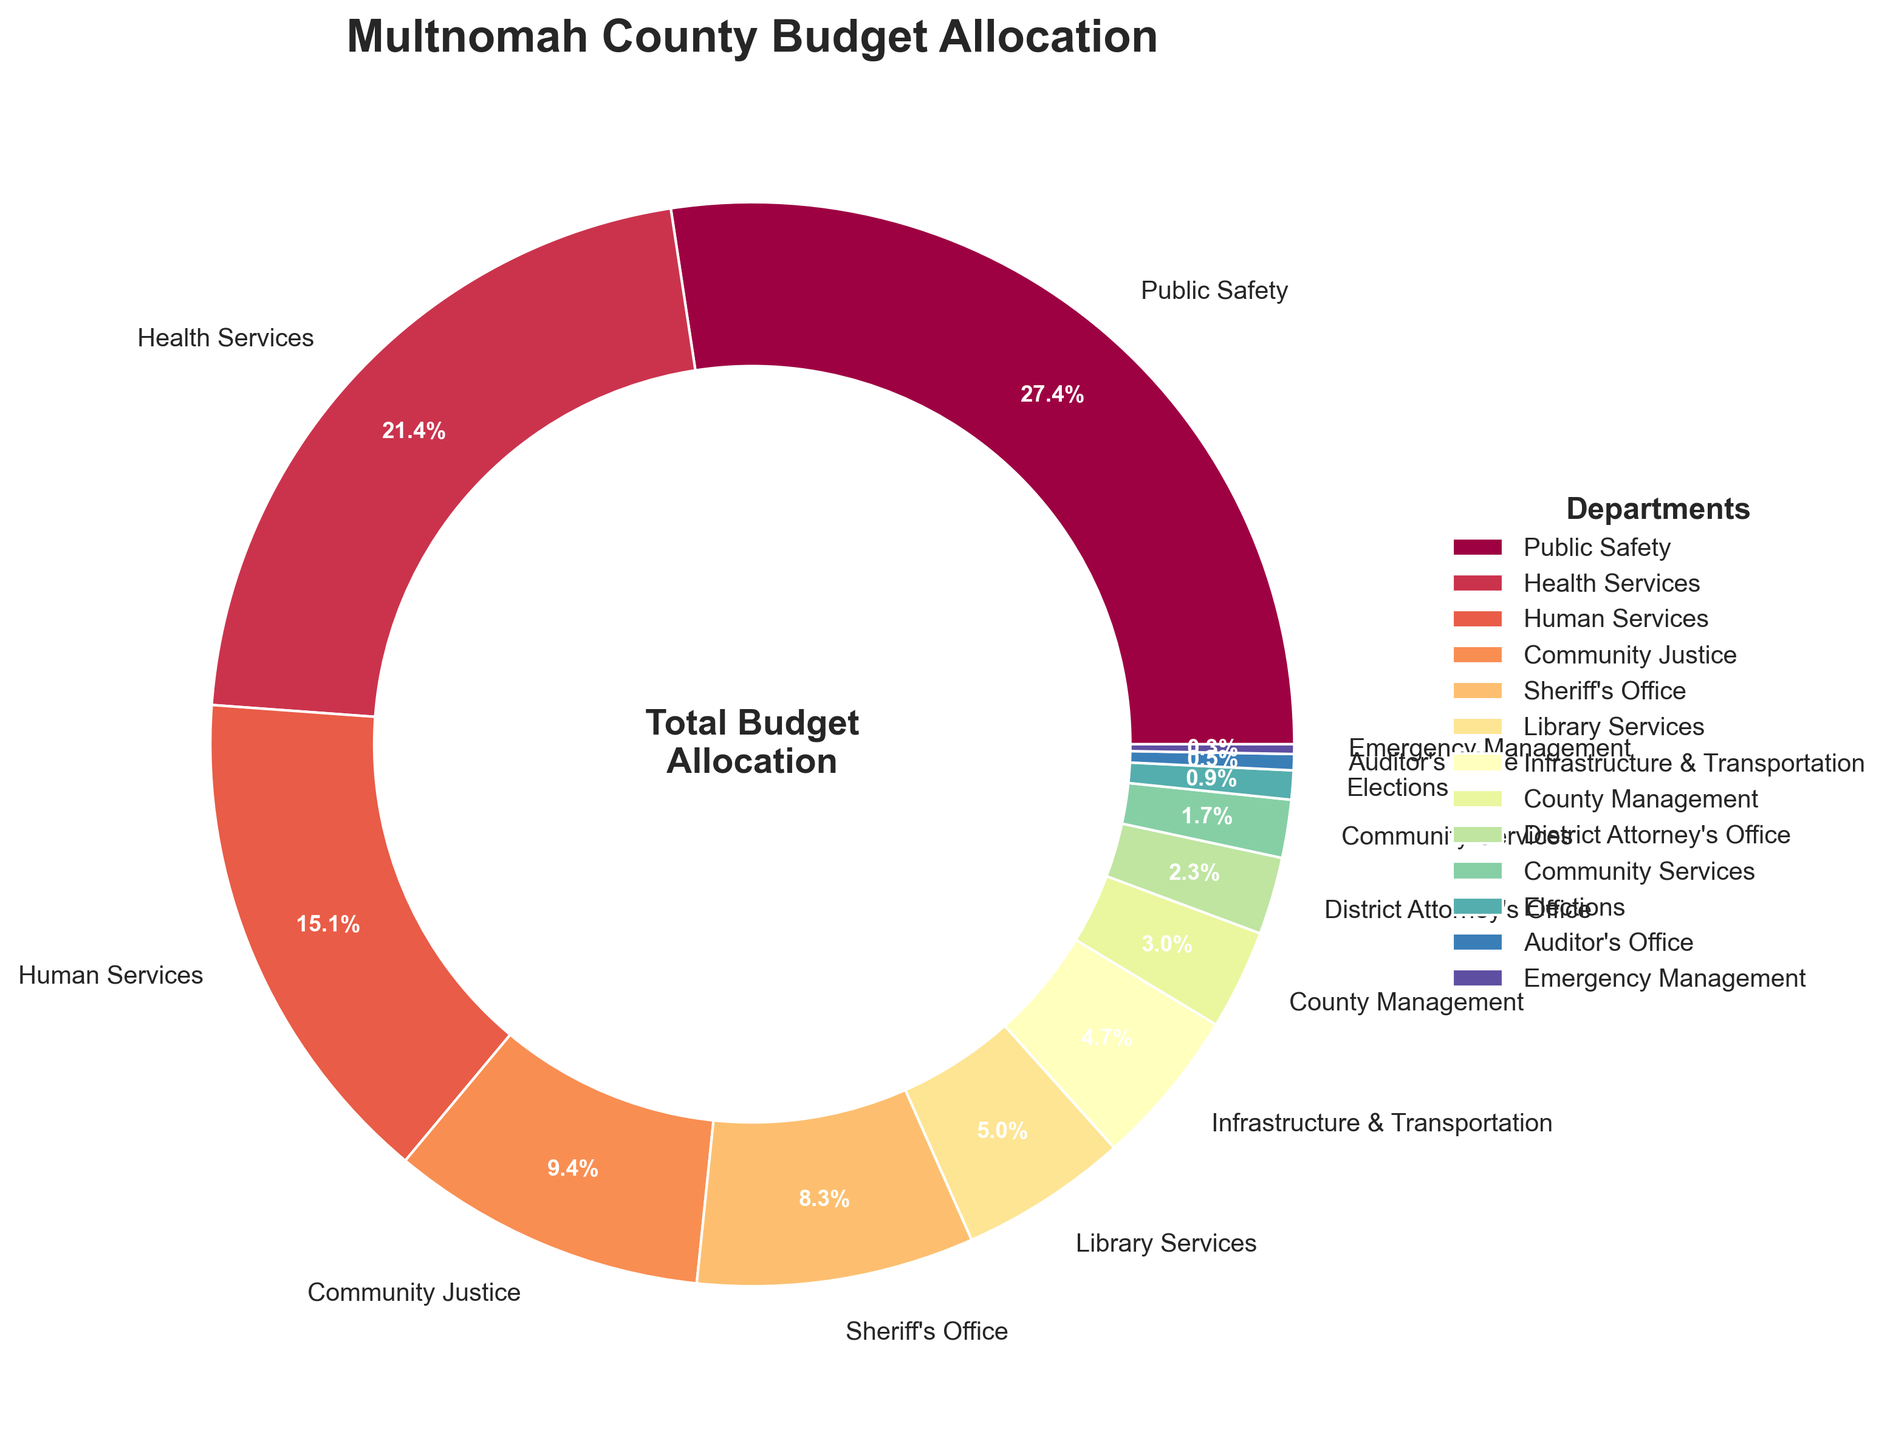What percentage of the budget is allocated to Public Safety and Health Services combined? To find this, add the budget allocations of Public Safety (28.5%) and Health Services (22.3%). Thus, 28.5 + 22.3 = 50.8%.
Answer: 50.8% Which department receives more of the budget, the Sheriff's Office or Community Justice? The Sheriff's Office receives 8.6% of the budget, while Community Justice receives 9.8%. Since 8.6% is less than 9.8%, Community Justice receives more.
Answer: Community Justice What is the total percentage allocated to Community Services, Elections, Auditor's Office, and Emergency Management combined? Add the budget allocations of Community Services (1.8%), Elections (0.9%), Auditor's Office (0.5%), and Emergency Management (0.3%). Thus, 1.8 + 0.9 + 0.5 + 0.3 = 3.5%.
Answer: 3.5% How much larger is the budget for Library Services compared to the Auditor's Office? The budget allocation for Library Services is 5.2% and for the Auditor's Office is 0.5%. Subtract the Auditor's Office budget from the Library Services budget: 5.2 - 0.5 = 4.7%.
Answer: 4.7% What visual element is used to represent the Department names in the chart? The Department names are represented as labels on the pie slices, and they are also included in the legend on the right side of the chart.
Answer: Labels and Legend Which department has the smallest budget allocation, and what is the percentage allocated to it? From the pie chart, Emergency Management has the smallest budget allocation at 0.3%.
Answer: Emergency Management, 0.3% If the budget for Health Services were increased by 5%, what would the new allocation percentage be? To find the new allocation, add 5% to the current Health Services budget of 22.3%. Thus, 22.3 + 5 = 27.3%.
Answer: 27.3% Compare the total budget allocation of Human Services and Infrastructure & Transportation. Which one is larger and by how much? The budget allocation for Human Services is 15.7%, and for Infrastructure & Transportation is 4.9%. Subtract Infrastructure & Transportation from Human Services: 15.7 - 4.9 = 10.8%. Human Services has the larger allocation by 10.8%.
Answer: Human Services, 10.8% 